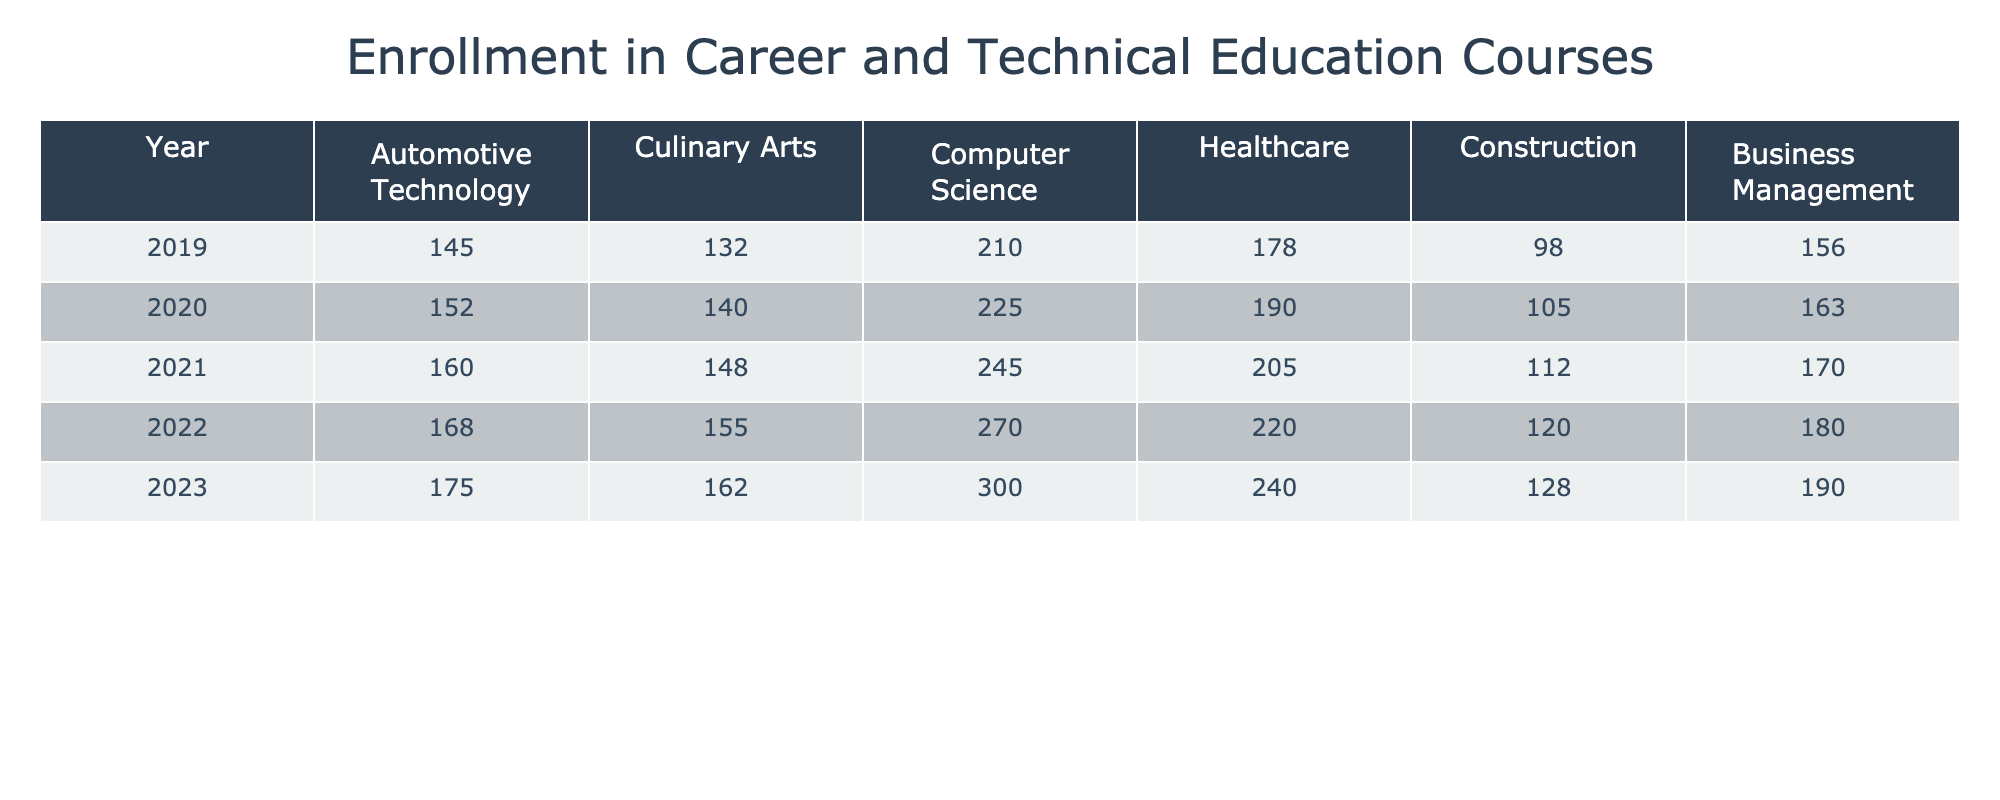What was the enrollment number for Computer Science in 2023? According to the table, the enrollment number for Computer Science in the year 2023 is listed directly in the corresponding cell under that column, which shows the value as 300.
Answer: 300 Which career and technical education course had the lowest enrollment in 2019? By examining the values in the 2019 row for all courses, the smallest number is 98, which corresponds to the Construction course.
Answer: Construction What course saw the highest increase in enrollment from 2019 to 2023? First, I will find the enrollment numbers for each course in 2019 and 2023. The increases are: Automotive Technology (30), Culinary Arts (30), Computer Science (90), Healthcare (62), Construction (30), and Business Management (34). The highest increase is 90 for Computer Science.
Answer: Computer Science What is the total enrollment for all courses in 2020? To calculate this, I will sum the enrollment numbers for all courses in 2020: 152 + 140 + 225 + 190 + 105 + 163 = 975.
Answer: 975 Did enrollment in Culinary Arts increase each year from 2019 to 2023? I will examine the Culinary Arts enrollment numbers from each year: 132, 140, 148, 155, and 162. Since each number is higher than the previous year's number, the answer is yes.
Answer: Yes What are the average enrollment numbers for all courses in 2022? I will sum the enrollment numbers for 2022 (168 + 155 + 270 + 220 + 120 + 180) = 1113, and then divide by the number of courses (6) to find the average: 1113 / 6 = 185.5.
Answer: 185.5 What is the difference in enrollment numbers for Healthcare between 2021 and 2023? The Healthcare enrollment numbers are 205 for 2021 and 240 for 2023. To find the difference, I will subtract 205 from 240, resulting in 35.
Answer: 35 Which course had a total enrollment of 128 in 2023? By checking the enrollment numbers in the 2023 row, the course corresponding to 128 is Construction.
Answer: Construction If we combine the enrollments for Automotive Technology and Healthcare in 2022, what will that total be? I will check the enrollment numbers: Automotive Technology (168) and Healthcare (220) for 2022. Adding these gives 168 + 220 = 388.
Answer: 388 In which year did Computer Science first exceed 250 enrollments? Looking through the enrollment numbers for Computer Science over the years, it first exceeds 250 in the year 2021 when the enrollment is 245, which is the last number below 250. The enrollment in 2022 increases to 270.
Answer: 2022 